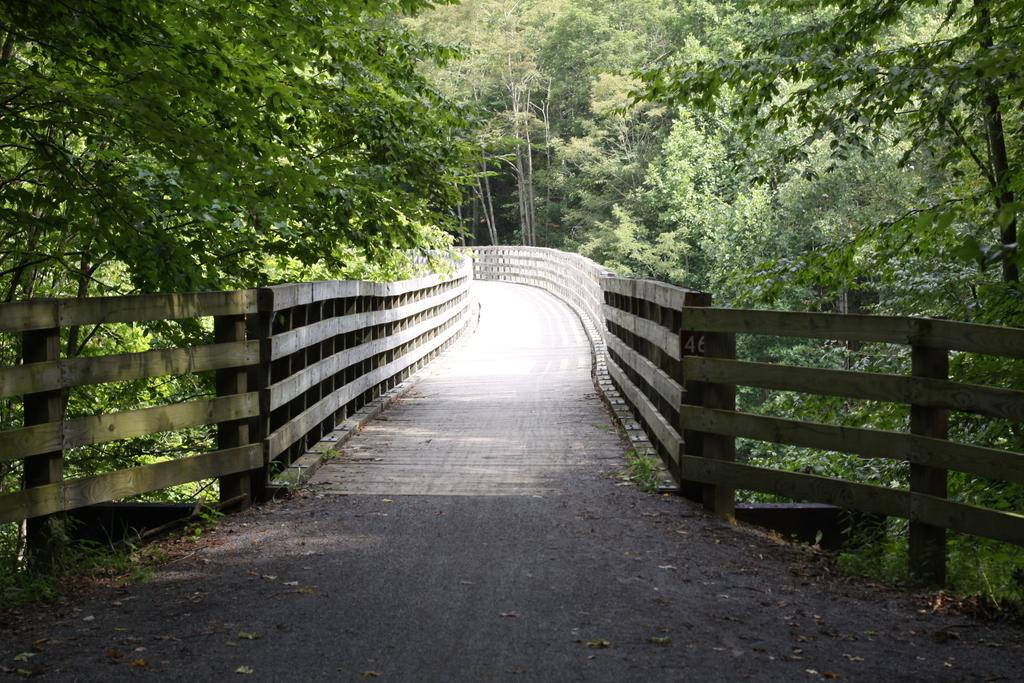What type of structure is present in the image? There is a wooden bridge in the image. What can be seen in the background of the image? There are trees with branches and leaves in the image. What type of news can be heard coming from the tomatoes in the image? There are no tomatoes present in the image, and therefore no news can be heard from them. 